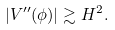Convert formula to latex. <formula><loc_0><loc_0><loc_500><loc_500>| V ^ { \prime \prime } ( \phi ) | \gtrsim H ^ { 2 } .</formula> 